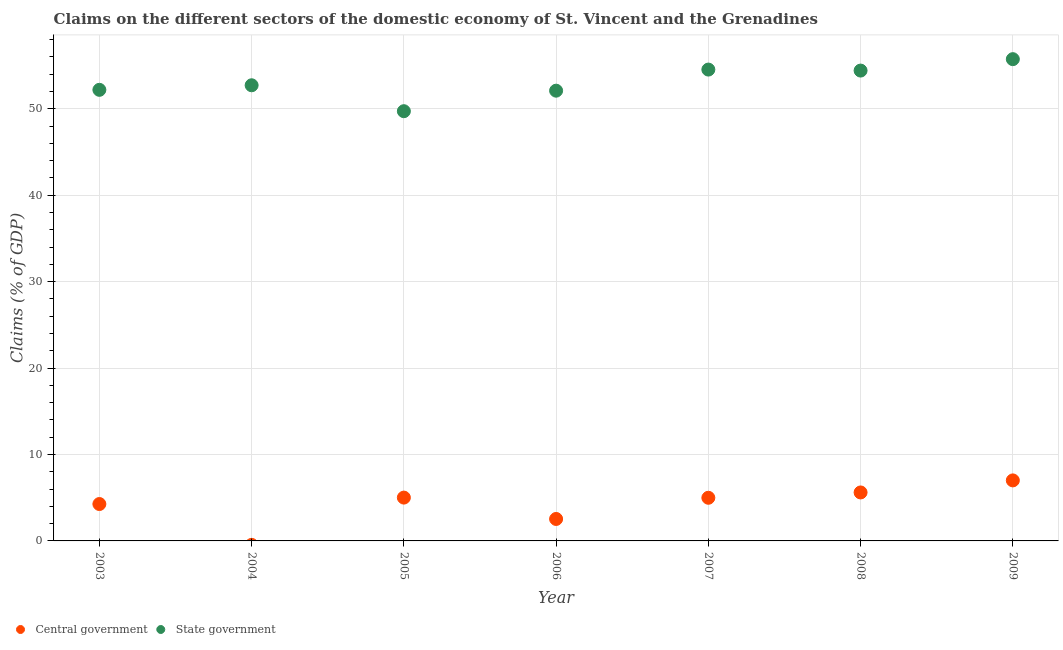What is the claims on state government in 2009?
Offer a terse response. 55.74. Across all years, what is the maximum claims on state government?
Offer a terse response. 55.74. Across all years, what is the minimum claims on central government?
Make the answer very short. 0. What is the total claims on state government in the graph?
Offer a terse response. 371.41. What is the difference between the claims on state government in 2007 and that in 2009?
Your response must be concise. -1.21. What is the difference between the claims on central government in 2007 and the claims on state government in 2006?
Your answer should be very brief. -47.1. What is the average claims on state government per year?
Your answer should be compact. 53.06. In the year 2003, what is the difference between the claims on central government and claims on state government?
Ensure brevity in your answer.  -47.92. In how many years, is the claims on state government greater than 50 %?
Ensure brevity in your answer.  6. What is the ratio of the claims on central government in 2003 to that in 2005?
Offer a terse response. 0.85. What is the difference between the highest and the second highest claims on central government?
Keep it short and to the point. 1.39. What is the difference between the highest and the lowest claims on central government?
Your answer should be compact. 7. Is the sum of the claims on state government in 2003 and 2005 greater than the maximum claims on central government across all years?
Offer a terse response. Yes. Is the claims on central government strictly less than the claims on state government over the years?
Offer a terse response. Yes. How many dotlines are there?
Your response must be concise. 2. How many years are there in the graph?
Offer a terse response. 7. What is the difference between two consecutive major ticks on the Y-axis?
Provide a succinct answer. 10. Are the values on the major ticks of Y-axis written in scientific E-notation?
Give a very brief answer. No. Where does the legend appear in the graph?
Your response must be concise. Bottom left. How are the legend labels stacked?
Provide a succinct answer. Horizontal. What is the title of the graph?
Your answer should be compact. Claims on the different sectors of the domestic economy of St. Vincent and the Grenadines. What is the label or title of the Y-axis?
Your response must be concise. Claims (% of GDP). What is the Claims (% of GDP) in Central government in 2003?
Give a very brief answer. 4.27. What is the Claims (% of GDP) of State government in 2003?
Ensure brevity in your answer.  52.19. What is the Claims (% of GDP) in Central government in 2004?
Ensure brevity in your answer.  0. What is the Claims (% of GDP) of State government in 2004?
Give a very brief answer. 52.72. What is the Claims (% of GDP) of Central government in 2005?
Provide a succinct answer. 5.01. What is the Claims (% of GDP) of State government in 2005?
Offer a very short reply. 49.72. What is the Claims (% of GDP) of Central government in 2006?
Give a very brief answer. 2.54. What is the Claims (% of GDP) in State government in 2006?
Provide a short and direct response. 52.09. What is the Claims (% of GDP) of Central government in 2007?
Give a very brief answer. 4.99. What is the Claims (% of GDP) in State government in 2007?
Your answer should be very brief. 54.53. What is the Claims (% of GDP) in Central government in 2008?
Your answer should be very brief. 5.61. What is the Claims (% of GDP) of State government in 2008?
Your answer should be very brief. 54.42. What is the Claims (% of GDP) of Central government in 2009?
Ensure brevity in your answer.  7. What is the Claims (% of GDP) in State government in 2009?
Provide a succinct answer. 55.74. Across all years, what is the maximum Claims (% of GDP) in Central government?
Provide a succinct answer. 7. Across all years, what is the maximum Claims (% of GDP) in State government?
Provide a short and direct response. 55.74. Across all years, what is the minimum Claims (% of GDP) of State government?
Your answer should be very brief. 49.72. What is the total Claims (% of GDP) in Central government in the graph?
Keep it short and to the point. 29.42. What is the total Claims (% of GDP) in State government in the graph?
Your response must be concise. 371.41. What is the difference between the Claims (% of GDP) of State government in 2003 and that in 2004?
Give a very brief answer. -0.53. What is the difference between the Claims (% of GDP) in Central government in 2003 and that in 2005?
Your answer should be compact. -0.74. What is the difference between the Claims (% of GDP) in State government in 2003 and that in 2005?
Your answer should be very brief. 2.47. What is the difference between the Claims (% of GDP) in Central government in 2003 and that in 2006?
Keep it short and to the point. 1.73. What is the difference between the Claims (% of GDP) of State government in 2003 and that in 2006?
Offer a very short reply. 0.1. What is the difference between the Claims (% of GDP) in Central government in 2003 and that in 2007?
Provide a short and direct response. -0.72. What is the difference between the Claims (% of GDP) of State government in 2003 and that in 2007?
Your answer should be very brief. -2.34. What is the difference between the Claims (% of GDP) in Central government in 2003 and that in 2008?
Make the answer very short. -1.34. What is the difference between the Claims (% of GDP) in State government in 2003 and that in 2008?
Your answer should be compact. -2.23. What is the difference between the Claims (% of GDP) of Central government in 2003 and that in 2009?
Your response must be concise. -2.73. What is the difference between the Claims (% of GDP) in State government in 2003 and that in 2009?
Provide a succinct answer. -3.55. What is the difference between the Claims (% of GDP) of State government in 2004 and that in 2005?
Provide a succinct answer. 3. What is the difference between the Claims (% of GDP) of State government in 2004 and that in 2006?
Your answer should be compact. 0.63. What is the difference between the Claims (% of GDP) in State government in 2004 and that in 2007?
Your response must be concise. -1.82. What is the difference between the Claims (% of GDP) in State government in 2004 and that in 2008?
Your answer should be compact. -1.7. What is the difference between the Claims (% of GDP) of State government in 2004 and that in 2009?
Give a very brief answer. -3.02. What is the difference between the Claims (% of GDP) of Central government in 2005 and that in 2006?
Give a very brief answer. 2.47. What is the difference between the Claims (% of GDP) in State government in 2005 and that in 2006?
Offer a very short reply. -2.37. What is the difference between the Claims (% of GDP) in Central government in 2005 and that in 2007?
Offer a terse response. 0.02. What is the difference between the Claims (% of GDP) of State government in 2005 and that in 2007?
Provide a succinct answer. -4.82. What is the difference between the Claims (% of GDP) in Central government in 2005 and that in 2008?
Make the answer very short. -0.6. What is the difference between the Claims (% of GDP) in State government in 2005 and that in 2008?
Your response must be concise. -4.7. What is the difference between the Claims (% of GDP) in Central government in 2005 and that in 2009?
Keep it short and to the point. -1.99. What is the difference between the Claims (% of GDP) of State government in 2005 and that in 2009?
Your answer should be very brief. -6.02. What is the difference between the Claims (% of GDP) in Central government in 2006 and that in 2007?
Offer a terse response. -2.45. What is the difference between the Claims (% of GDP) of State government in 2006 and that in 2007?
Offer a very short reply. -2.44. What is the difference between the Claims (% of GDP) of Central government in 2006 and that in 2008?
Keep it short and to the point. -3.07. What is the difference between the Claims (% of GDP) in State government in 2006 and that in 2008?
Provide a short and direct response. -2.33. What is the difference between the Claims (% of GDP) in Central government in 2006 and that in 2009?
Your response must be concise. -4.46. What is the difference between the Claims (% of GDP) of State government in 2006 and that in 2009?
Offer a very short reply. -3.65. What is the difference between the Claims (% of GDP) of Central government in 2007 and that in 2008?
Ensure brevity in your answer.  -0.62. What is the difference between the Claims (% of GDP) in State government in 2007 and that in 2008?
Keep it short and to the point. 0.12. What is the difference between the Claims (% of GDP) in Central government in 2007 and that in 2009?
Offer a terse response. -2.01. What is the difference between the Claims (% of GDP) in State government in 2007 and that in 2009?
Provide a succinct answer. -1.21. What is the difference between the Claims (% of GDP) in Central government in 2008 and that in 2009?
Your answer should be compact. -1.39. What is the difference between the Claims (% of GDP) in State government in 2008 and that in 2009?
Offer a terse response. -1.32. What is the difference between the Claims (% of GDP) of Central government in 2003 and the Claims (% of GDP) of State government in 2004?
Keep it short and to the point. -48.45. What is the difference between the Claims (% of GDP) of Central government in 2003 and the Claims (% of GDP) of State government in 2005?
Make the answer very short. -45.45. What is the difference between the Claims (% of GDP) of Central government in 2003 and the Claims (% of GDP) of State government in 2006?
Make the answer very short. -47.82. What is the difference between the Claims (% of GDP) in Central government in 2003 and the Claims (% of GDP) in State government in 2007?
Offer a very short reply. -50.27. What is the difference between the Claims (% of GDP) of Central government in 2003 and the Claims (% of GDP) of State government in 2008?
Keep it short and to the point. -50.15. What is the difference between the Claims (% of GDP) in Central government in 2003 and the Claims (% of GDP) in State government in 2009?
Offer a very short reply. -51.47. What is the difference between the Claims (% of GDP) of Central government in 2005 and the Claims (% of GDP) of State government in 2006?
Provide a succinct answer. -47.08. What is the difference between the Claims (% of GDP) of Central government in 2005 and the Claims (% of GDP) of State government in 2007?
Your answer should be very brief. -49.52. What is the difference between the Claims (% of GDP) of Central government in 2005 and the Claims (% of GDP) of State government in 2008?
Make the answer very short. -49.41. What is the difference between the Claims (% of GDP) of Central government in 2005 and the Claims (% of GDP) of State government in 2009?
Offer a very short reply. -50.73. What is the difference between the Claims (% of GDP) of Central government in 2006 and the Claims (% of GDP) of State government in 2007?
Your answer should be compact. -51.99. What is the difference between the Claims (% of GDP) in Central government in 2006 and the Claims (% of GDP) in State government in 2008?
Offer a terse response. -51.88. What is the difference between the Claims (% of GDP) in Central government in 2006 and the Claims (% of GDP) in State government in 2009?
Keep it short and to the point. -53.2. What is the difference between the Claims (% of GDP) of Central government in 2007 and the Claims (% of GDP) of State government in 2008?
Make the answer very short. -49.43. What is the difference between the Claims (% of GDP) in Central government in 2007 and the Claims (% of GDP) in State government in 2009?
Keep it short and to the point. -50.75. What is the difference between the Claims (% of GDP) in Central government in 2008 and the Claims (% of GDP) in State government in 2009?
Provide a succinct answer. -50.13. What is the average Claims (% of GDP) in Central government per year?
Give a very brief answer. 4.2. What is the average Claims (% of GDP) in State government per year?
Your answer should be very brief. 53.06. In the year 2003, what is the difference between the Claims (% of GDP) of Central government and Claims (% of GDP) of State government?
Ensure brevity in your answer.  -47.92. In the year 2005, what is the difference between the Claims (% of GDP) in Central government and Claims (% of GDP) in State government?
Provide a short and direct response. -44.71. In the year 2006, what is the difference between the Claims (% of GDP) in Central government and Claims (% of GDP) in State government?
Provide a succinct answer. -49.55. In the year 2007, what is the difference between the Claims (% of GDP) of Central government and Claims (% of GDP) of State government?
Your answer should be compact. -49.54. In the year 2008, what is the difference between the Claims (% of GDP) in Central government and Claims (% of GDP) in State government?
Provide a succinct answer. -48.81. In the year 2009, what is the difference between the Claims (% of GDP) of Central government and Claims (% of GDP) of State government?
Your response must be concise. -48.74. What is the ratio of the Claims (% of GDP) of State government in 2003 to that in 2004?
Your response must be concise. 0.99. What is the ratio of the Claims (% of GDP) of Central government in 2003 to that in 2005?
Offer a terse response. 0.85. What is the ratio of the Claims (% of GDP) in State government in 2003 to that in 2005?
Ensure brevity in your answer.  1.05. What is the ratio of the Claims (% of GDP) in Central government in 2003 to that in 2006?
Offer a very short reply. 1.68. What is the ratio of the Claims (% of GDP) in Central government in 2003 to that in 2007?
Your response must be concise. 0.86. What is the ratio of the Claims (% of GDP) in State government in 2003 to that in 2007?
Offer a terse response. 0.96. What is the ratio of the Claims (% of GDP) in Central government in 2003 to that in 2008?
Offer a terse response. 0.76. What is the ratio of the Claims (% of GDP) of State government in 2003 to that in 2008?
Your answer should be compact. 0.96. What is the ratio of the Claims (% of GDP) in Central government in 2003 to that in 2009?
Provide a succinct answer. 0.61. What is the ratio of the Claims (% of GDP) in State government in 2003 to that in 2009?
Your answer should be compact. 0.94. What is the ratio of the Claims (% of GDP) in State government in 2004 to that in 2005?
Provide a succinct answer. 1.06. What is the ratio of the Claims (% of GDP) of State government in 2004 to that in 2006?
Provide a short and direct response. 1.01. What is the ratio of the Claims (% of GDP) in State government in 2004 to that in 2007?
Provide a short and direct response. 0.97. What is the ratio of the Claims (% of GDP) in State government in 2004 to that in 2008?
Keep it short and to the point. 0.97. What is the ratio of the Claims (% of GDP) of State government in 2004 to that in 2009?
Your answer should be compact. 0.95. What is the ratio of the Claims (% of GDP) in Central government in 2005 to that in 2006?
Offer a very short reply. 1.97. What is the ratio of the Claims (% of GDP) in State government in 2005 to that in 2006?
Give a very brief answer. 0.95. What is the ratio of the Claims (% of GDP) in State government in 2005 to that in 2007?
Offer a terse response. 0.91. What is the ratio of the Claims (% of GDP) of Central government in 2005 to that in 2008?
Provide a succinct answer. 0.89. What is the ratio of the Claims (% of GDP) in State government in 2005 to that in 2008?
Offer a very short reply. 0.91. What is the ratio of the Claims (% of GDP) of Central government in 2005 to that in 2009?
Give a very brief answer. 0.72. What is the ratio of the Claims (% of GDP) in State government in 2005 to that in 2009?
Offer a terse response. 0.89. What is the ratio of the Claims (% of GDP) of Central government in 2006 to that in 2007?
Ensure brevity in your answer.  0.51. What is the ratio of the Claims (% of GDP) of State government in 2006 to that in 2007?
Offer a very short reply. 0.96. What is the ratio of the Claims (% of GDP) in Central government in 2006 to that in 2008?
Your answer should be compact. 0.45. What is the ratio of the Claims (% of GDP) in State government in 2006 to that in 2008?
Your response must be concise. 0.96. What is the ratio of the Claims (% of GDP) in Central government in 2006 to that in 2009?
Ensure brevity in your answer.  0.36. What is the ratio of the Claims (% of GDP) of State government in 2006 to that in 2009?
Ensure brevity in your answer.  0.93. What is the ratio of the Claims (% of GDP) of Central government in 2007 to that in 2008?
Your answer should be compact. 0.89. What is the ratio of the Claims (% of GDP) in State government in 2007 to that in 2008?
Make the answer very short. 1. What is the ratio of the Claims (% of GDP) of Central government in 2007 to that in 2009?
Offer a terse response. 0.71. What is the ratio of the Claims (% of GDP) of State government in 2007 to that in 2009?
Make the answer very short. 0.98. What is the ratio of the Claims (% of GDP) of Central government in 2008 to that in 2009?
Offer a terse response. 0.8. What is the ratio of the Claims (% of GDP) of State government in 2008 to that in 2009?
Give a very brief answer. 0.98. What is the difference between the highest and the second highest Claims (% of GDP) of Central government?
Your response must be concise. 1.39. What is the difference between the highest and the second highest Claims (% of GDP) in State government?
Your answer should be compact. 1.21. What is the difference between the highest and the lowest Claims (% of GDP) of Central government?
Your answer should be very brief. 7. What is the difference between the highest and the lowest Claims (% of GDP) of State government?
Give a very brief answer. 6.02. 